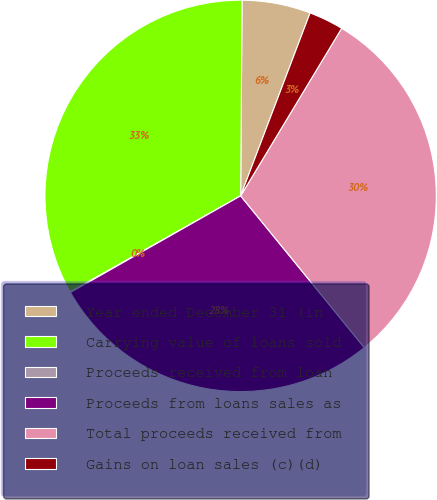Convert chart. <chart><loc_0><loc_0><loc_500><loc_500><pie_chart><fcel>Year ended December 31 (in<fcel>Carrying value of loans sold<fcel>Proceeds received from loan<fcel>Proceeds from loans sales as<fcel>Total proceeds received from<fcel>Gains on loan sales (c)(d)<nl><fcel>5.66%<fcel>33.28%<fcel>0.05%<fcel>27.67%<fcel>30.48%<fcel>2.86%<nl></chart> 